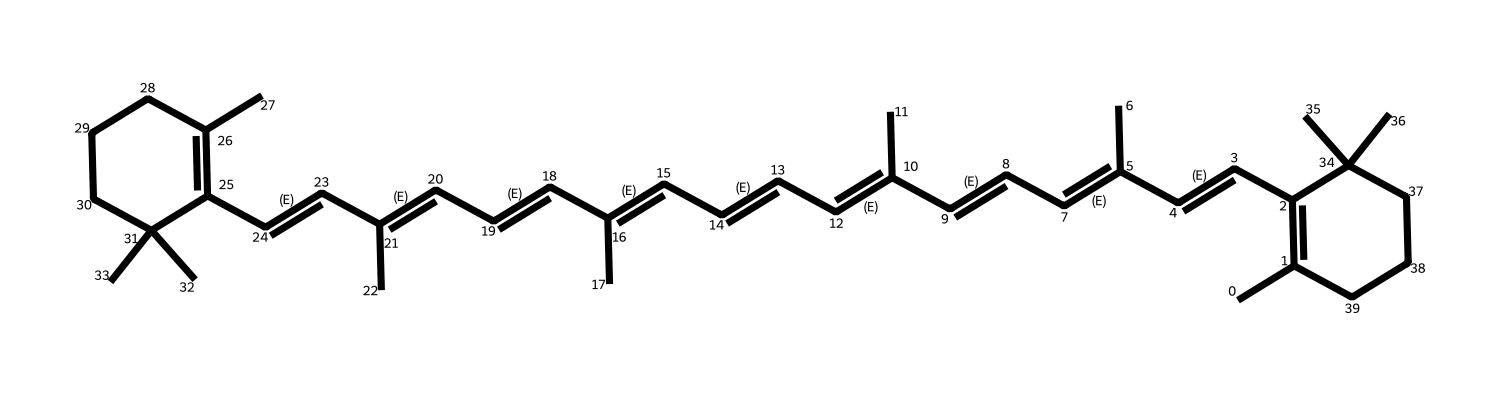What is the primary element found in beta-carotene? The SMILES representation indicates that the compound is mainly composed of carbon (C) and hydrogen (H), with no other elements shown explicitly. Therefore, carbon is the primary element in the structure.
Answer: carbon How many double bonds are present in the chemical structure of beta-carotene? By analyzing the SMILES, we can count the double bonds represented by the "=" signs connecting the carbon atoms. There are a total of eleven double bonds identified in the structure.
Answer: eleven What functional group is characteristic of beta-carotene? Beta-carotene is characterized by a polyene structure, which consists of multiple conjugated double bonds. This specific arrangement gives it its antioxidant properties, typical for carotenoids.
Answer: polyene What type of chemical compound is beta-carotene classified as? Given that beta-carotene contains a long chain of conjugated double bonds, it is classified as a carotenoid, which is a type of organic pigment.
Answer: carotenoid How many rings are present in beta-carotene's chemical structure? In the provided SMILES, there is one clear cycloalkane structure indicated by the "C1" and "C2" designation, which defines one cyclic component in its framework. Therefore, there is one ring in the structure.
Answer: one ring What role does beta-carotene play in camouflage paints? Beta-carotene contributes to the vibrant colors and is used for its light-absorbing properties, enhancing the effectiveness of camouflage paints during World War II.
Answer: colorant 